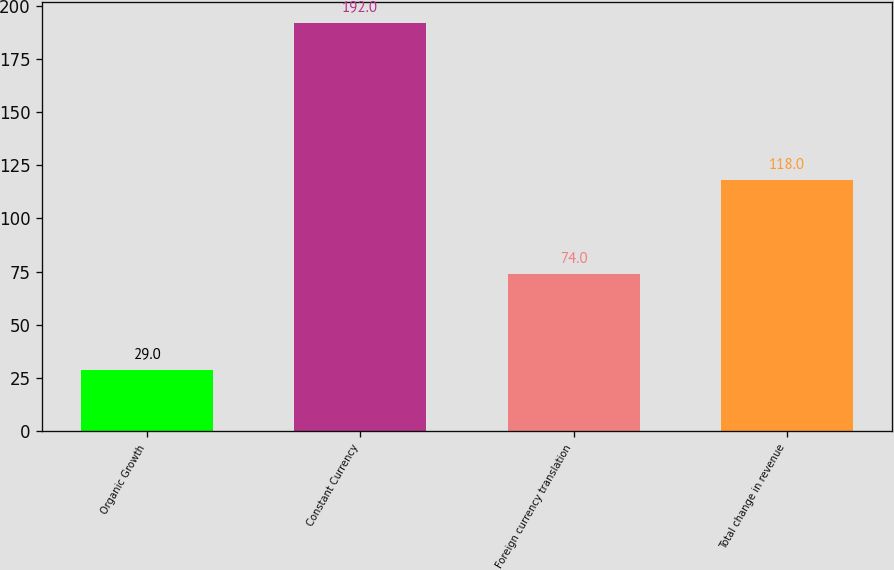Convert chart. <chart><loc_0><loc_0><loc_500><loc_500><bar_chart><fcel>Organic Growth<fcel>Constant Currency<fcel>Foreign currency translation<fcel>Total change in revenue<nl><fcel>29<fcel>192<fcel>74<fcel>118<nl></chart> 